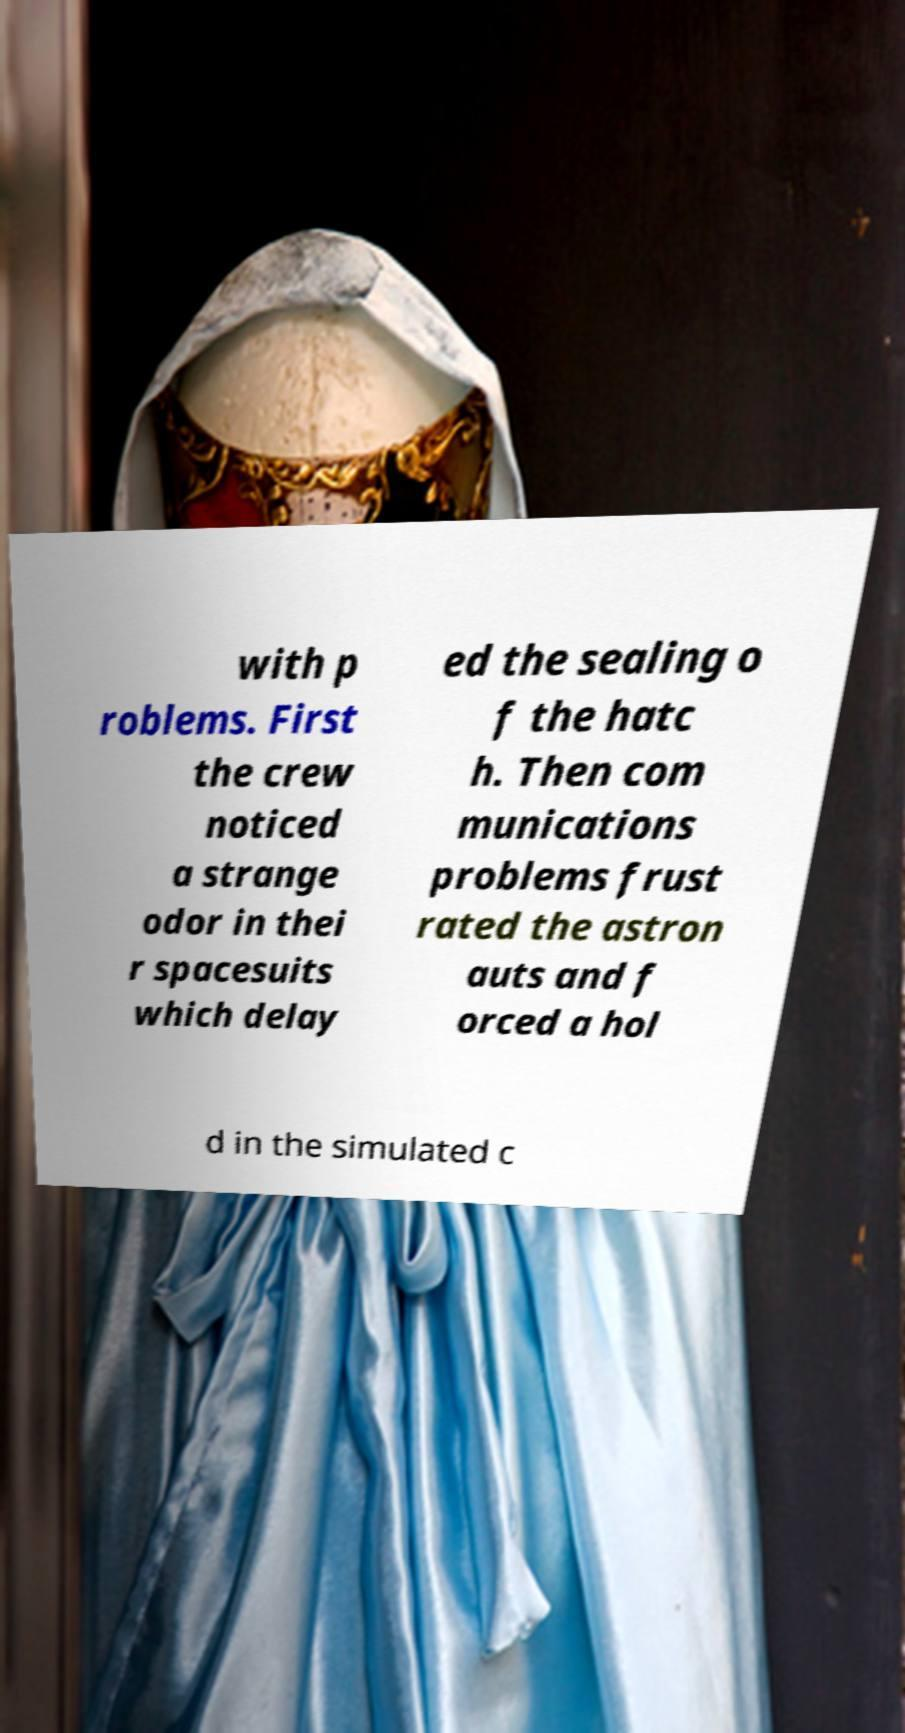Can you accurately transcribe the text from the provided image for me? with p roblems. First the crew noticed a strange odor in thei r spacesuits which delay ed the sealing o f the hatc h. Then com munications problems frust rated the astron auts and f orced a hol d in the simulated c 